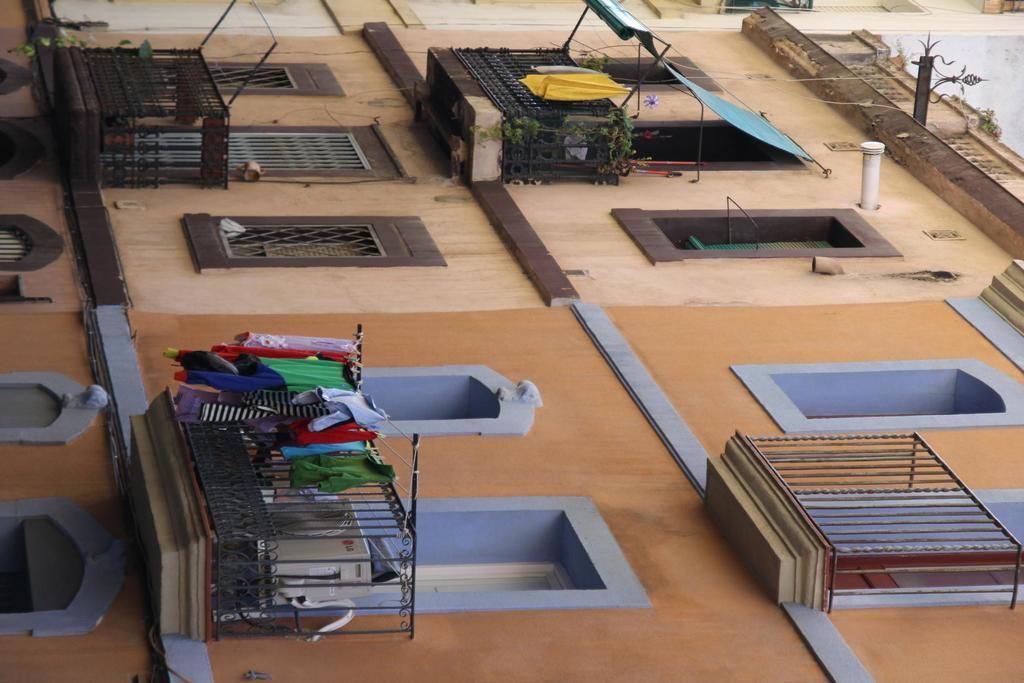What is the main structure in the center of the image? There is a building in the center of the image. What other architectural feature can be seen in the image? There is a wall in the image. What can be observed about the building's design? The building has windows. What type of items are present in the image? Clothes are present in the image, along with a few other objects. Can you see a ghost interacting with the clothes in the image? There is no ghost present in the image, and therefore no interaction with the clothes can be observed. 